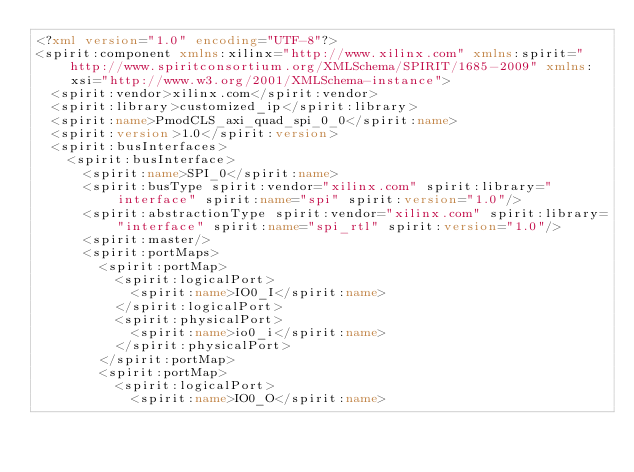<code> <loc_0><loc_0><loc_500><loc_500><_XML_><?xml version="1.0" encoding="UTF-8"?>
<spirit:component xmlns:xilinx="http://www.xilinx.com" xmlns:spirit="http://www.spiritconsortium.org/XMLSchema/SPIRIT/1685-2009" xmlns:xsi="http://www.w3.org/2001/XMLSchema-instance">
  <spirit:vendor>xilinx.com</spirit:vendor>
  <spirit:library>customized_ip</spirit:library>
  <spirit:name>PmodCLS_axi_quad_spi_0_0</spirit:name>
  <spirit:version>1.0</spirit:version>
  <spirit:busInterfaces>
    <spirit:busInterface>
      <spirit:name>SPI_0</spirit:name>
      <spirit:busType spirit:vendor="xilinx.com" spirit:library="interface" spirit:name="spi" spirit:version="1.0"/>
      <spirit:abstractionType spirit:vendor="xilinx.com" spirit:library="interface" spirit:name="spi_rtl" spirit:version="1.0"/>
      <spirit:master/>
      <spirit:portMaps>
        <spirit:portMap>
          <spirit:logicalPort>
            <spirit:name>IO0_I</spirit:name>
          </spirit:logicalPort>
          <spirit:physicalPort>
            <spirit:name>io0_i</spirit:name>
          </spirit:physicalPort>
        </spirit:portMap>
        <spirit:portMap>
          <spirit:logicalPort>
            <spirit:name>IO0_O</spirit:name></code> 